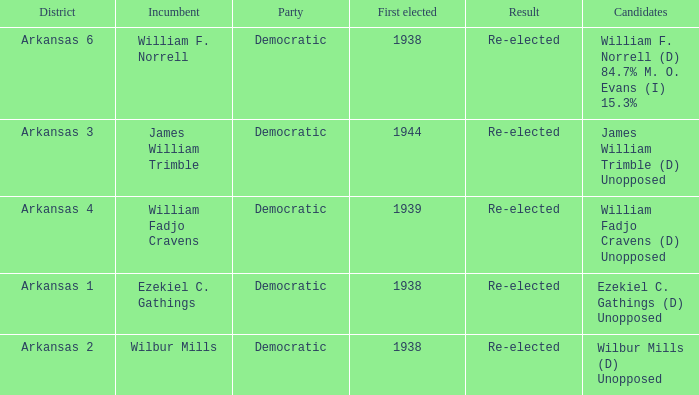Would you mind parsing the complete table? {'header': ['District', 'Incumbent', 'Party', 'First elected', 'Result', 'Candidates'], 'rows': [['Arkansas 6', 'William F. Norrell', 'Democratic', '1938', 'Re-elected', 'William F. Norrell (D) 84.7% M. O. Evans (I) 15.3%'], ['Arkansas 3', 'James William Trimble', 'Democratic', '1944', 'Re-elected', 'James William Trimble (D) Unopposed'], ['Arkansas 4', 'William Fadjo Cravens', 'Democratic', '1939', 'Re-elected', 'William Fadjo Cravens (D) Unopposed'], ['Arkansas 1', 'Ezekiel C. Gathings', 'Democratic', '1938', 'Re-elected', 'Ezekiel C. Gathings (D) Unopposed'], ['Arkansas 2', 'Wilbur Mills', 'Democratic', '1938', 'Re-elected', 'Wilbur Mills (D) Unopposed']]} How many were first elected in the Arkansas 4 district? 1.0. 